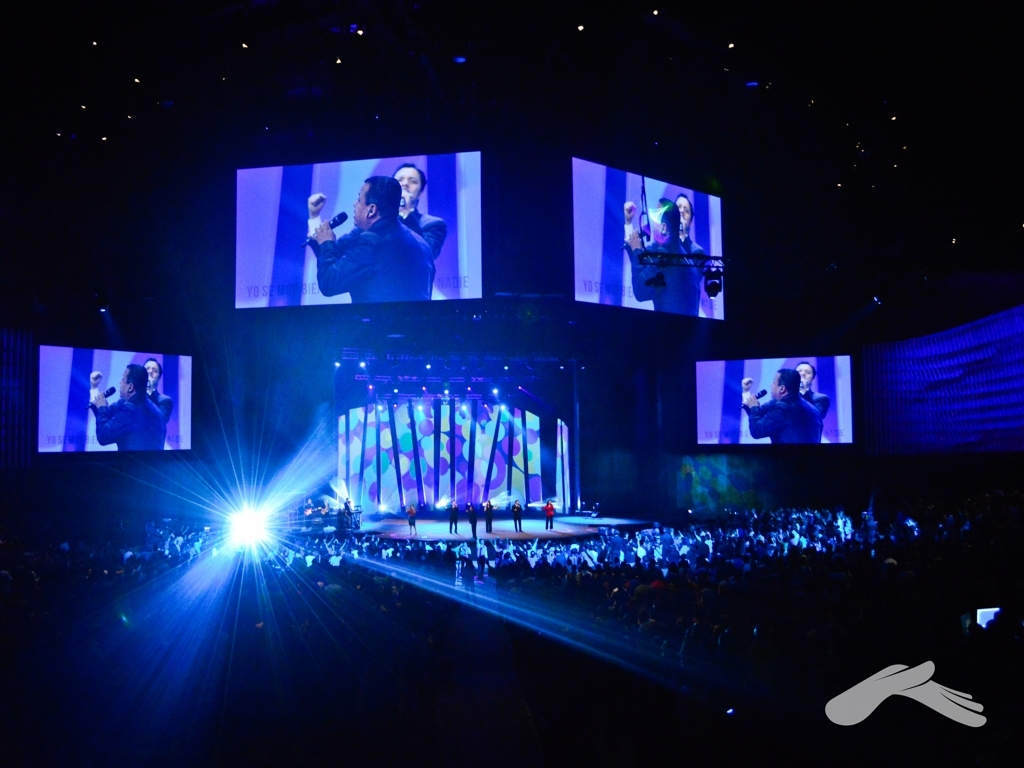Is the overall lighting of the image sufficient? The image exhibits a dynamic range of lighting conditions, with a strong centralized light source projecting towards the audience, creating a highlighted effect on the stage. While the foreground and audience are dimly lit, presumably to focus attention on the performance and create ambiance, the stage and screens are well illuminated. The lighting design appears intentional for a live performance setting, enhancing the visual experience. 